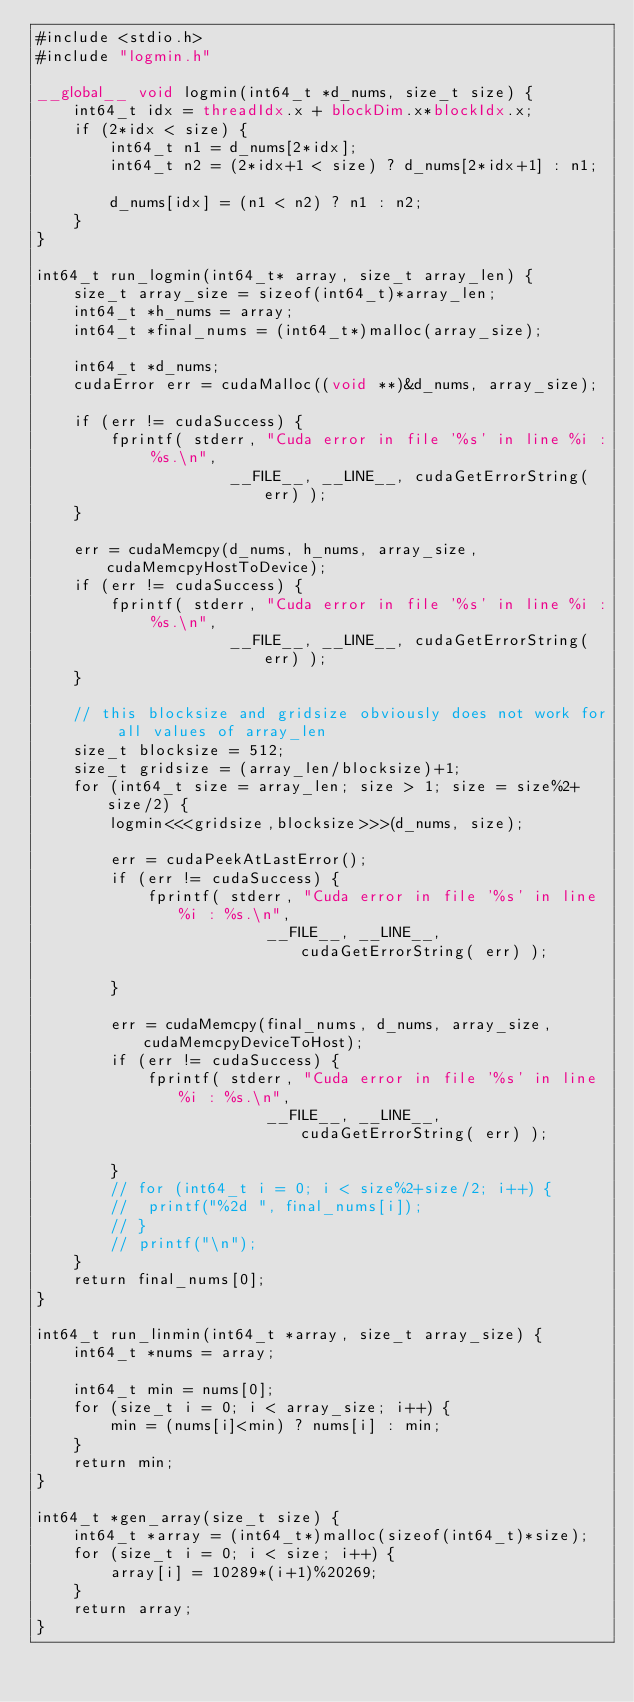<code> <loc_0><loc_0><loc_500><loc_500><_Cuda_>#include <stdio.h>
#include "logmin.h"

__global__ void logmin(int64_t *d_nums, size_t size) {
	int64_t idx = threadIdx.x + blockDim.x*blockIdx.x;
	if (2*idx < size) {
		int64_t n1 = d_nums[2*idx];
		int64_t n2 = (2*idx+1 < size) ? d_nums[2*idx+1] : n1;

		d_nums[idx] = (n1 < n2) ? n1 : n2;
	}
}

int64_t run_logmin(int64_t* array, size_t array_len) {
	size_t array_size = sizeof(int64_t)*array_len;
	int64_t *h_nums = array;
	int64_t *final_nums = (int64_t*)malloc(array_size);

	int64_t *d_nums;
	cudaError err = cudaMalloc((void **)&d_nums, array_size);
	
	if (err != cudaSuccess) {
		fprintf( stderr, "Cuda error in file '%s' in line %i : %s.\n",
					 __FILE__, __LINE__, cudaGetErrorString( err) );		
	}

	err = cudaMemcpy(d_nums, h_nums, array_size, cudaMemcpyHostToDevice);
	if (err != cudaSuccess) {
		fprintf( stderr, "Cuda error in file '%s' in line %i : %s.\n",
					 __FILE__, __LINE__, cudaGetErrorString( err) );		
	}

	// this blocksize and gridsize obviously does not work for all values of array_len
	size_t blocksize = 512;
	size_t gridsize = (array_len/blocksize)+1;
	for (int64_t size = array_len; size > 1; size = size%2+size/2) {
		logmin<<<gridsize,blocksize>>>(d_nums, size);

		err = cudaPeekAtLastError();
		if (err != cudaSuccess) {
			fprintf( stderr, "Cuda error in file '%s' in line %i : %s.\n",
						 __FILE__, __LINE__, cudaGetErrorString( err) );		
		}

		err = cudaMemcpy(final_nums, d_nums, array_size, cudaMemcpyDeviceToHost);
		if (err != cudaSuccess) {
			fprintf( stderr, "Cuda error in file '%s' in line %i : %s.\n",
						 __FILE__, __LINE__, cudaGetErrorString( err) );		
		}
		// for (int64_t i = 0; i < size%2+size/2; i++) {
		// 	printf("%2d ", final_nums[i]);
		// }
		// printf("\n");
	}
	return final_nums[0];
}

int64_t run_linmin(int64_t *array, size_t array_size) {
	int64_t *nums = array;

	int64_t min = nums[0];
	for (size_t i = 0; i < array_size; i++) {
		min = (nums[i]<min) ? nums[i] : min;
	}
	return min;
}

int64_t *gen_array(size_t size) {
	int64_t *array = (int64_t*)malloc(sizeof(int64_t)*size);
	for (size_t i = 0; i < size; i++) {
		array[i] = 10289*(i+1)%20269;
	}
	return array;
}
</code> 